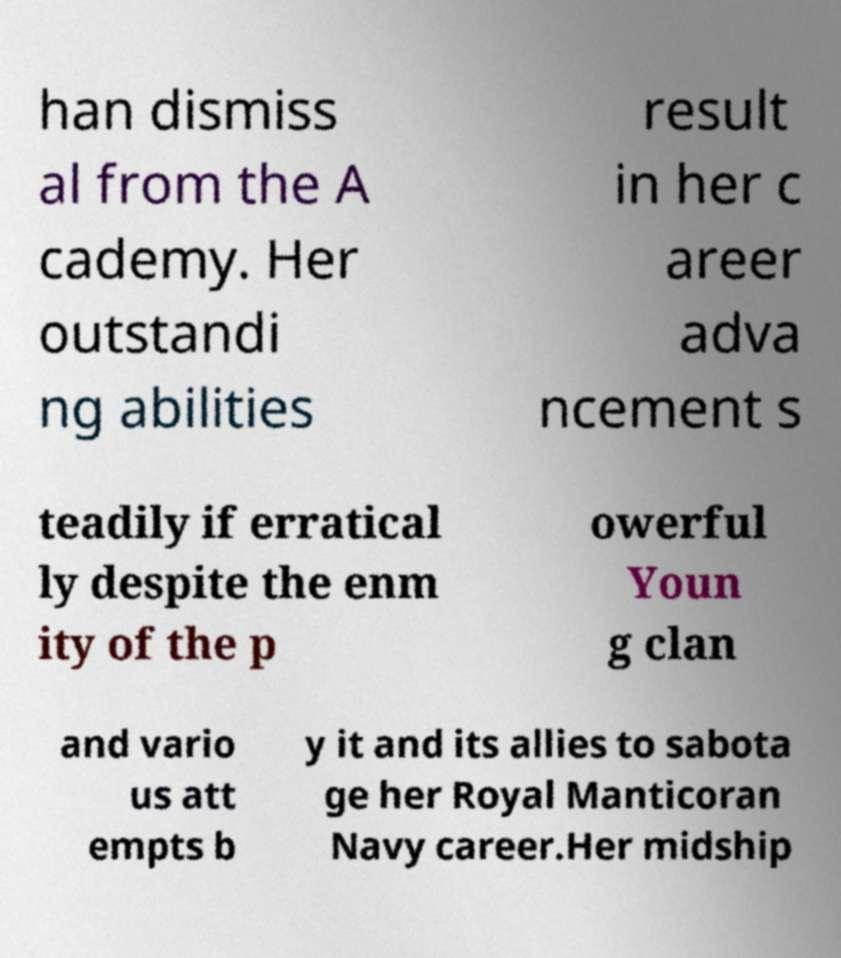Can you accurately transcribe the text from the provided image for me? han dismiss al from the A cademy. Her outstandi ng abilities result in her c areer adva ncement s teadily if erratical ly despite the enm ity of the p owerful Youn g clan and vario us att empts b y it and its allies to sabota ge her Royal Manticoran Navy career.Her midship 